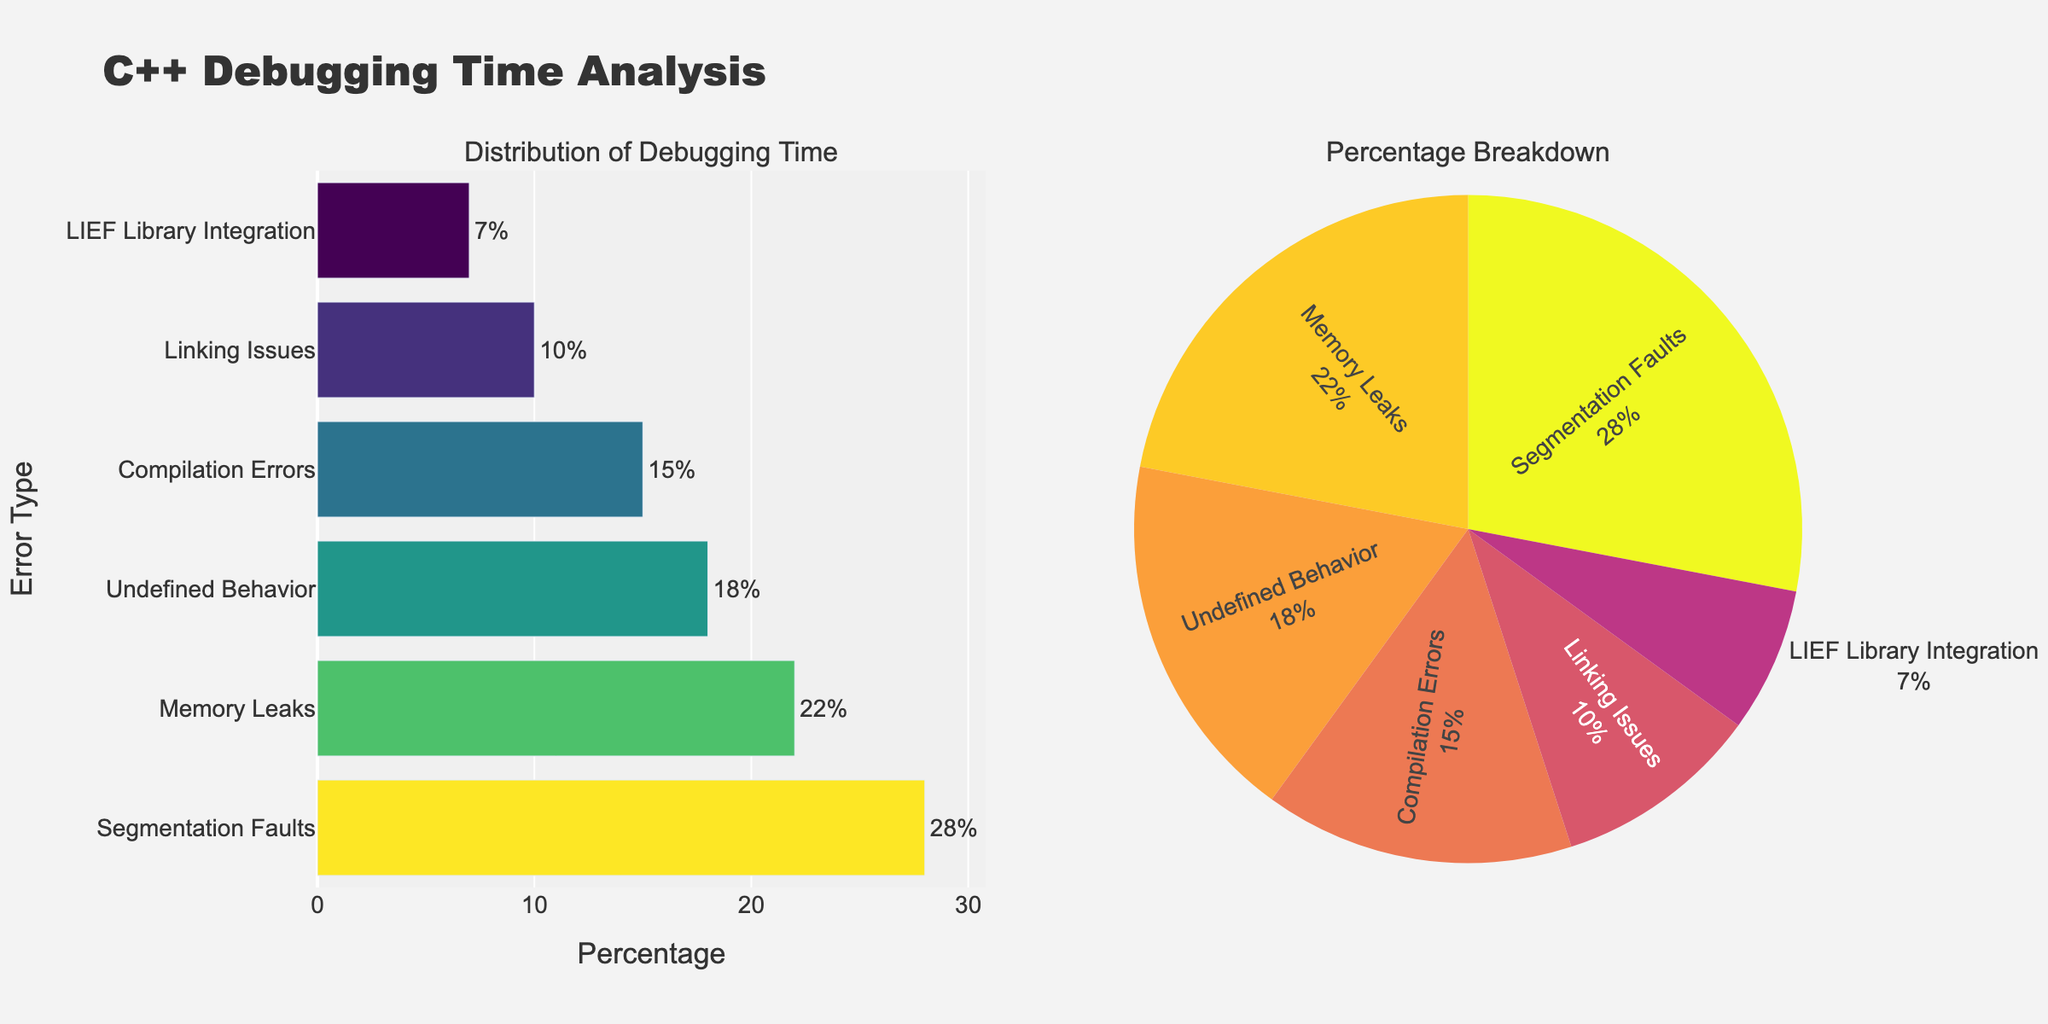How many different types of errors are represented in the figure? To determine the number of different error types, count the distinct labels on the y-axis of the bar chart or the pie slices. There are six error types: Segmentation Faults, Memory Leaks, Undefined Behavior, Compilation Errors, Linking Issues, and LIEF Library Integration.
Answer: Six Which error type has the highest percentage of debugging time? Look at the bar chart in the left subplot to identify the bar that reaches the furthest along the x-axis. The tallest bar is labeled 'Segmentation Faults' with a percentage of 28%.
Answer: Segmentation Faults What is the combined percentage of debugging time for Memory Leaks and Undefined Behavior? Sum the percentages of Memory Leaks and Undefined Behavior by finding their values in the bar chart or pie chart. Memory Leaks is 22% and Undefined Behavior is 18%. Thus, their combined percentage is 22% + 18% = 40%.
Answer: 40% Which error type has the smallest representation in debugging time? Find the smallest bar in the bar chart or the smallest slice in the pie chart. The 'LIEF Library Integration' has the smallest percentage of debugging time at 7%.
Answer: LIEF Library Integration How does the percentage of time spent on Compilation Errors compare to Linking Issues? Compare the lengths of the bars for Compilation Errors and Linking Issues or their slices in the pie chart. Compilation Errors has a percentage of 15%, whereas Linking Issues has a percentage of 10%. Therefore, Compilation Errors have a higher percentage.
Answer: Compilation Errors are higher What percentage of time is spent on errors related to the LIEF Library Integration compared to the sum of Compilation Errors and Linking Issues? First, find the percentage for LIEF Library Integration, which is 7%. Then, sum the percentages for Compilation Errors and Linking Issues (15% + 10% = 25%). The comparison is between 7% and 25%, so the percentage for LIEF Library Integration is lower.
Answer: LIEF Library Integration is lower What is the average percentage of debugging time for the top three error types? Identify the top three error types based on their percentages: Segmentation Faults (28%), Memory Leaks (22%), and Undefined Behavior (18%). Calculate their average: (28 + 22 + 18) / 3 = 68 / 3 = approximately 22.67%.
Answer: 22.67% If the percentage for Undefined Behavior increased by 5%, what would be the new percentage? Add 5% to the current percentage of Undefined Behavior, which is 18%. The new percentage would be 18% + 5% = 23%.
Answer: 23% What is the ratio of debugging time for Segmentation Faults to LIEF Library Integration? Find the percentages for Segmentation Faults and LIEF Library Integration (28% and 7%, respectively). The ratio is calculated as 28 / 7 = 4:1.
Answer: 4:1 Is the percentage of debugging time for Memory Leaks more than double that of Linking Issues? Check the percentages for Memory Leaks (22%) and Linking Issues (10%). Since 22 is indeed more than 20 (which is double of 10), the debugging time for Memory Leaks is more than double.
Answer: Yes 